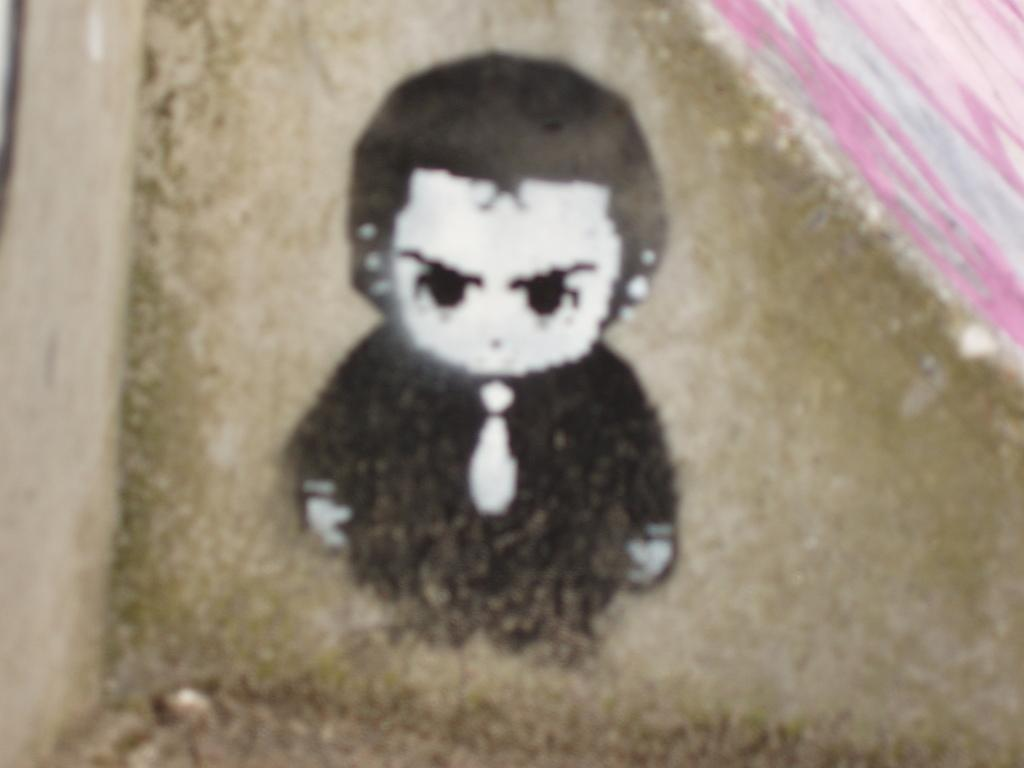What is the main subject of the image? There is a person depicted in the image. Can you describe the background of the image? The background of the image is colored. What type of stem can be seen in the image? There is no stem present in the image; it features a person and a colored background. 